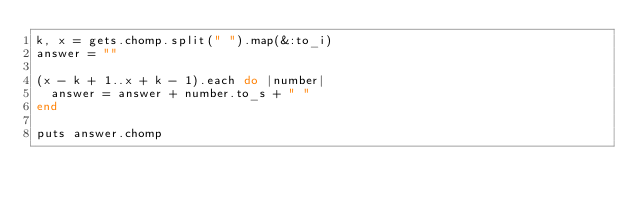Convert code to text. <code><loc_0><loc_0><loc_500><loc_500><_Ruby_>k, x = gets.chomp.split(" ").map(&:to_i)
answer = ""

(x - k + 1..x + k - 1).each do |number|
  answer = answer + number.to_s + " "
end

puts answer.chomp</code> 